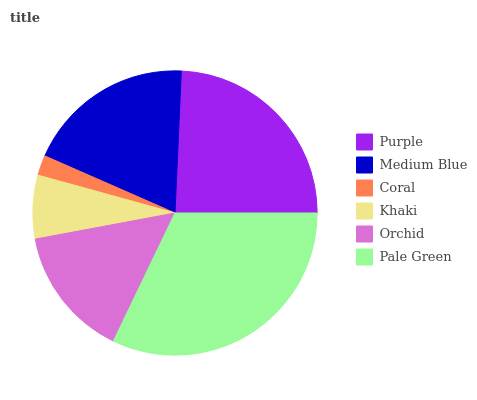Is Coral the minimum?
Answer yes or no. Yes. Is Pale Green the maximum?
Answer yes or no. Yes. Is Medium Blue the minimum?
Answer yes or no. No. Is Medium Blue the maximum?
Answer yes or no. No. Is Purple greater than Medium Blue?
Answer yes or no. Yes. Is Medium Blue less than Purple?
Answer yes or no. Yes. Is Medium Blue greater than Purple?
Answer yes or no. No. Is Purple less than Medium Blue?
Answer yes or no. No. Is Medium Blue the high median?
Answer yes or no. Yes. Is Orchid the low median?
Answer yes or no. Yes. Is Orchid the high median?
Answer yes or no. No. Is Purple the low median?
Answer yes or no. No. 